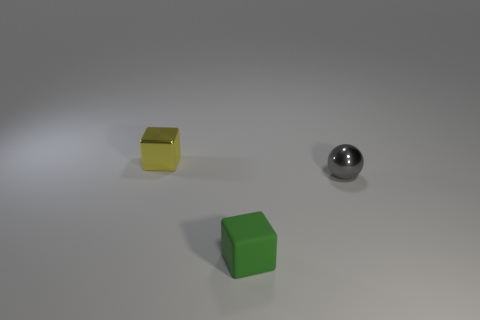Subtract all yellow cubes. How many cubes are left? 1 Subtract all spheres. How many objects are left? 2 Subtract 2 blocks. How many blocks are left? 0 Add 2 yellow cubes. How many objects exist? 5 Subtract 0 red spheres. How many objects are left? 3 Subtract all green blocks. Subtract all gray spheres. How many blocks are left? 1 Subtract all yellow blocks. How many yellow spheres are left? 0 Subtract all tiny metallic balls. Subtract all red metallic blocks. How many objects are left? 2 Add 3 small gray objects. How many small gray objects are left? 4 Add 1 gray cylinders. How many gray cylinders exist? 1 